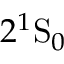Convert formula to latex. <formula><loc_0><loc_0><loc_500><loc_500>2 ^ { 1 } S _ { 0 }</formula> 